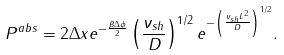<formula> <loc_0><loc_0><loc_500><loc_500>P ^ { a b s } = 2 \Delta x e ^ { - \frac { \beta \Delta \phi } 2 } \left ( \frac { \nu _ { s h } } D \right ) ^ { 1 / 2 } e ^ { - \left ( \frac { \nu _ { s h } L ^ { 2 } } D \right ) ^ { 1 / 2 } } .</formula> 